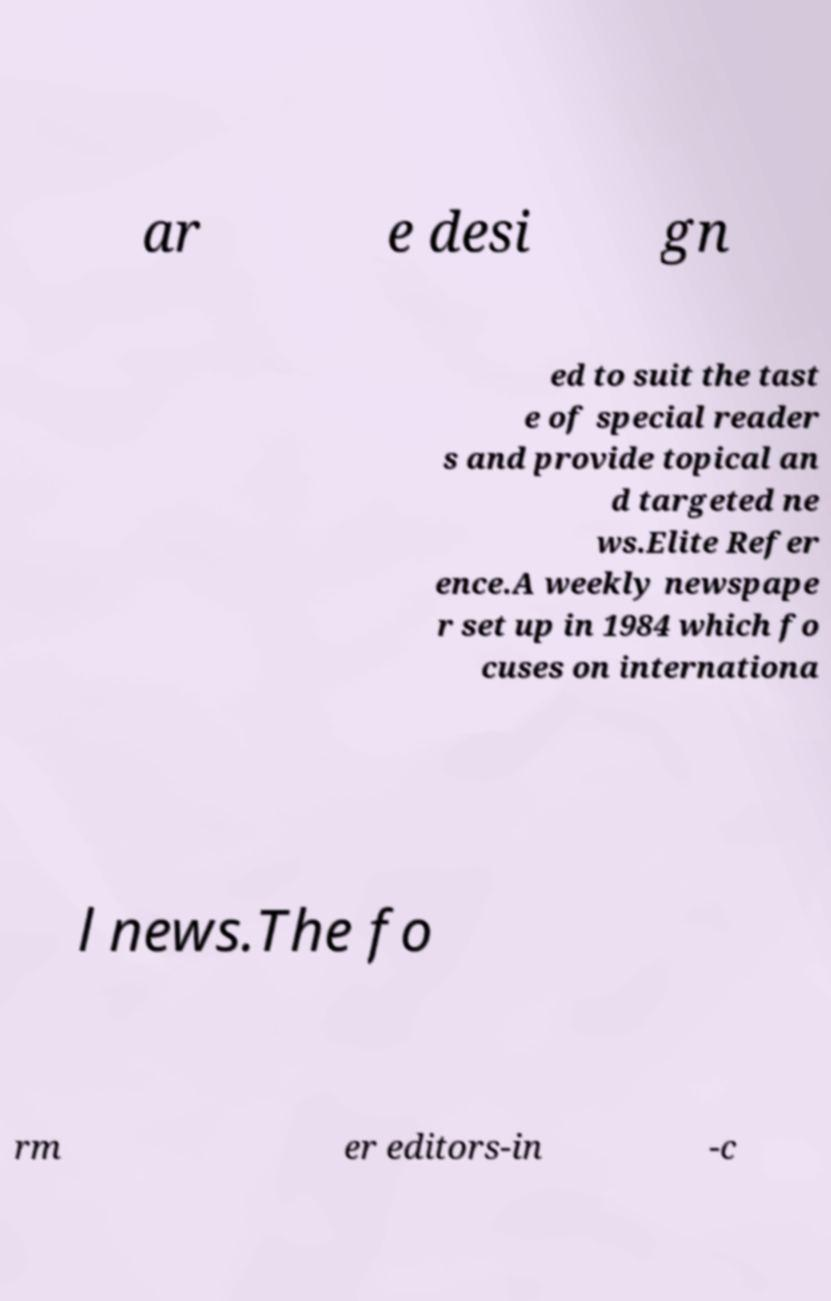Please read and relay the text visible in this image. What does it say? ar e desi gn ed to suit the tast e of special reader s and provide topical an d targeted ne ws.Elite Refer ence.A weekly newspape r set up in 1984 which fo cuses on internationa l news.The fo rm er editors-in -c 